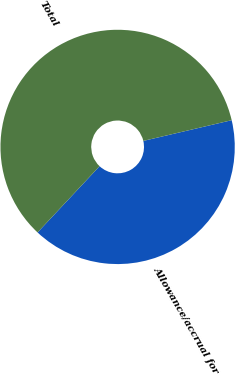<chart> <loc_0><loc_0><loc_500><loc_500><pie_chart><fcel>Allowance/accrual for<fcel>Total<nl><fcel>40.64%<fcel>59.36%<nl></chart> 